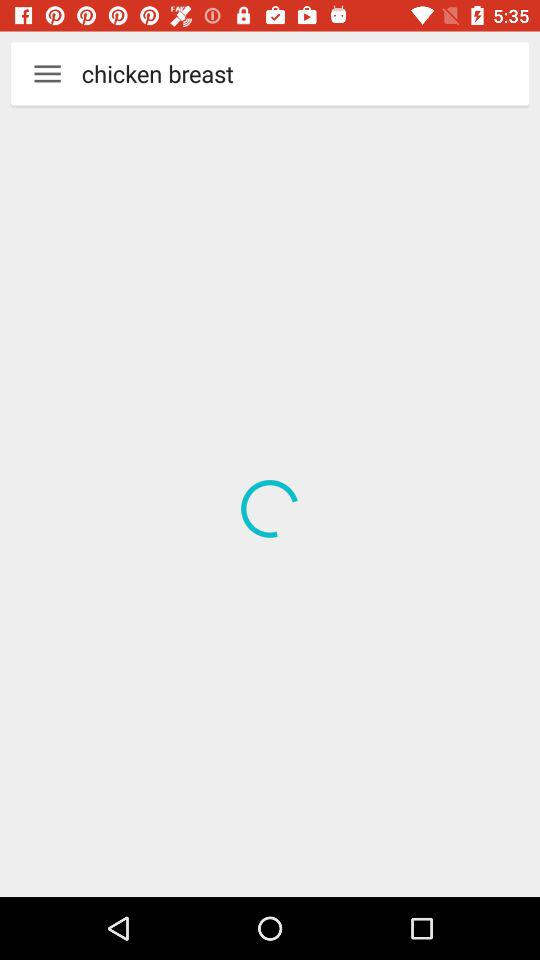How long does it take to prepare the eggless cake using cake mix?
When the provided information is insufficient, respond with <no answer>. <no answer> 